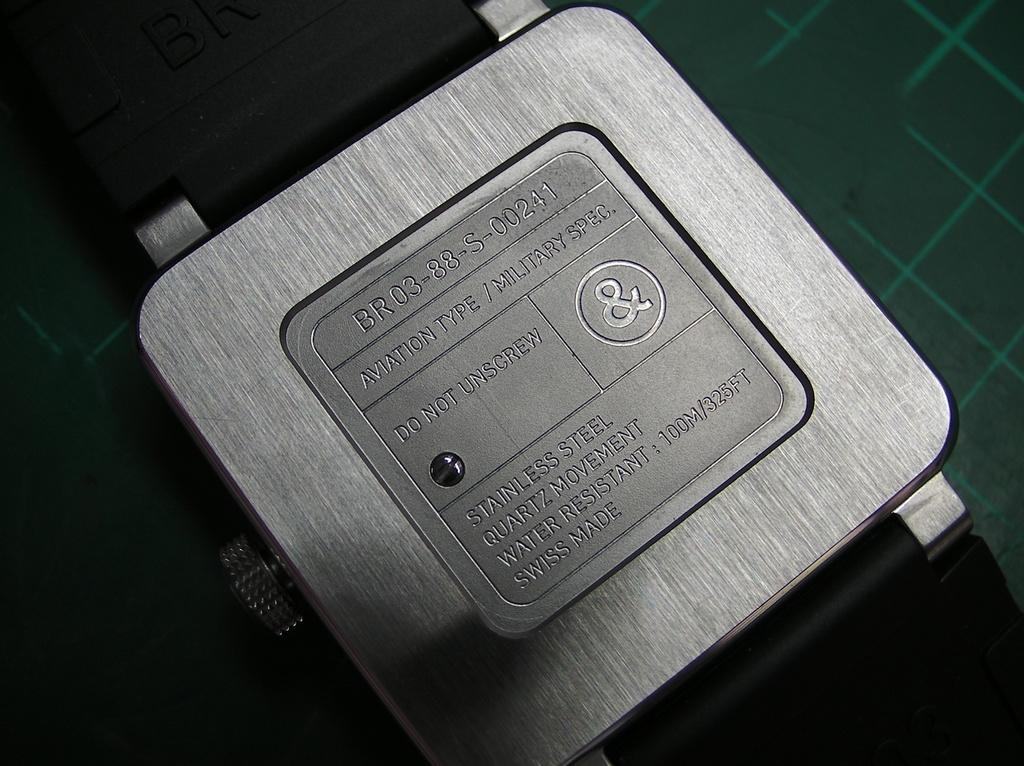This label warns you to not what?
Offer a very short reply. Unscrew. What should you not do?
Ensure brevity in your answer.  Unscrew. 